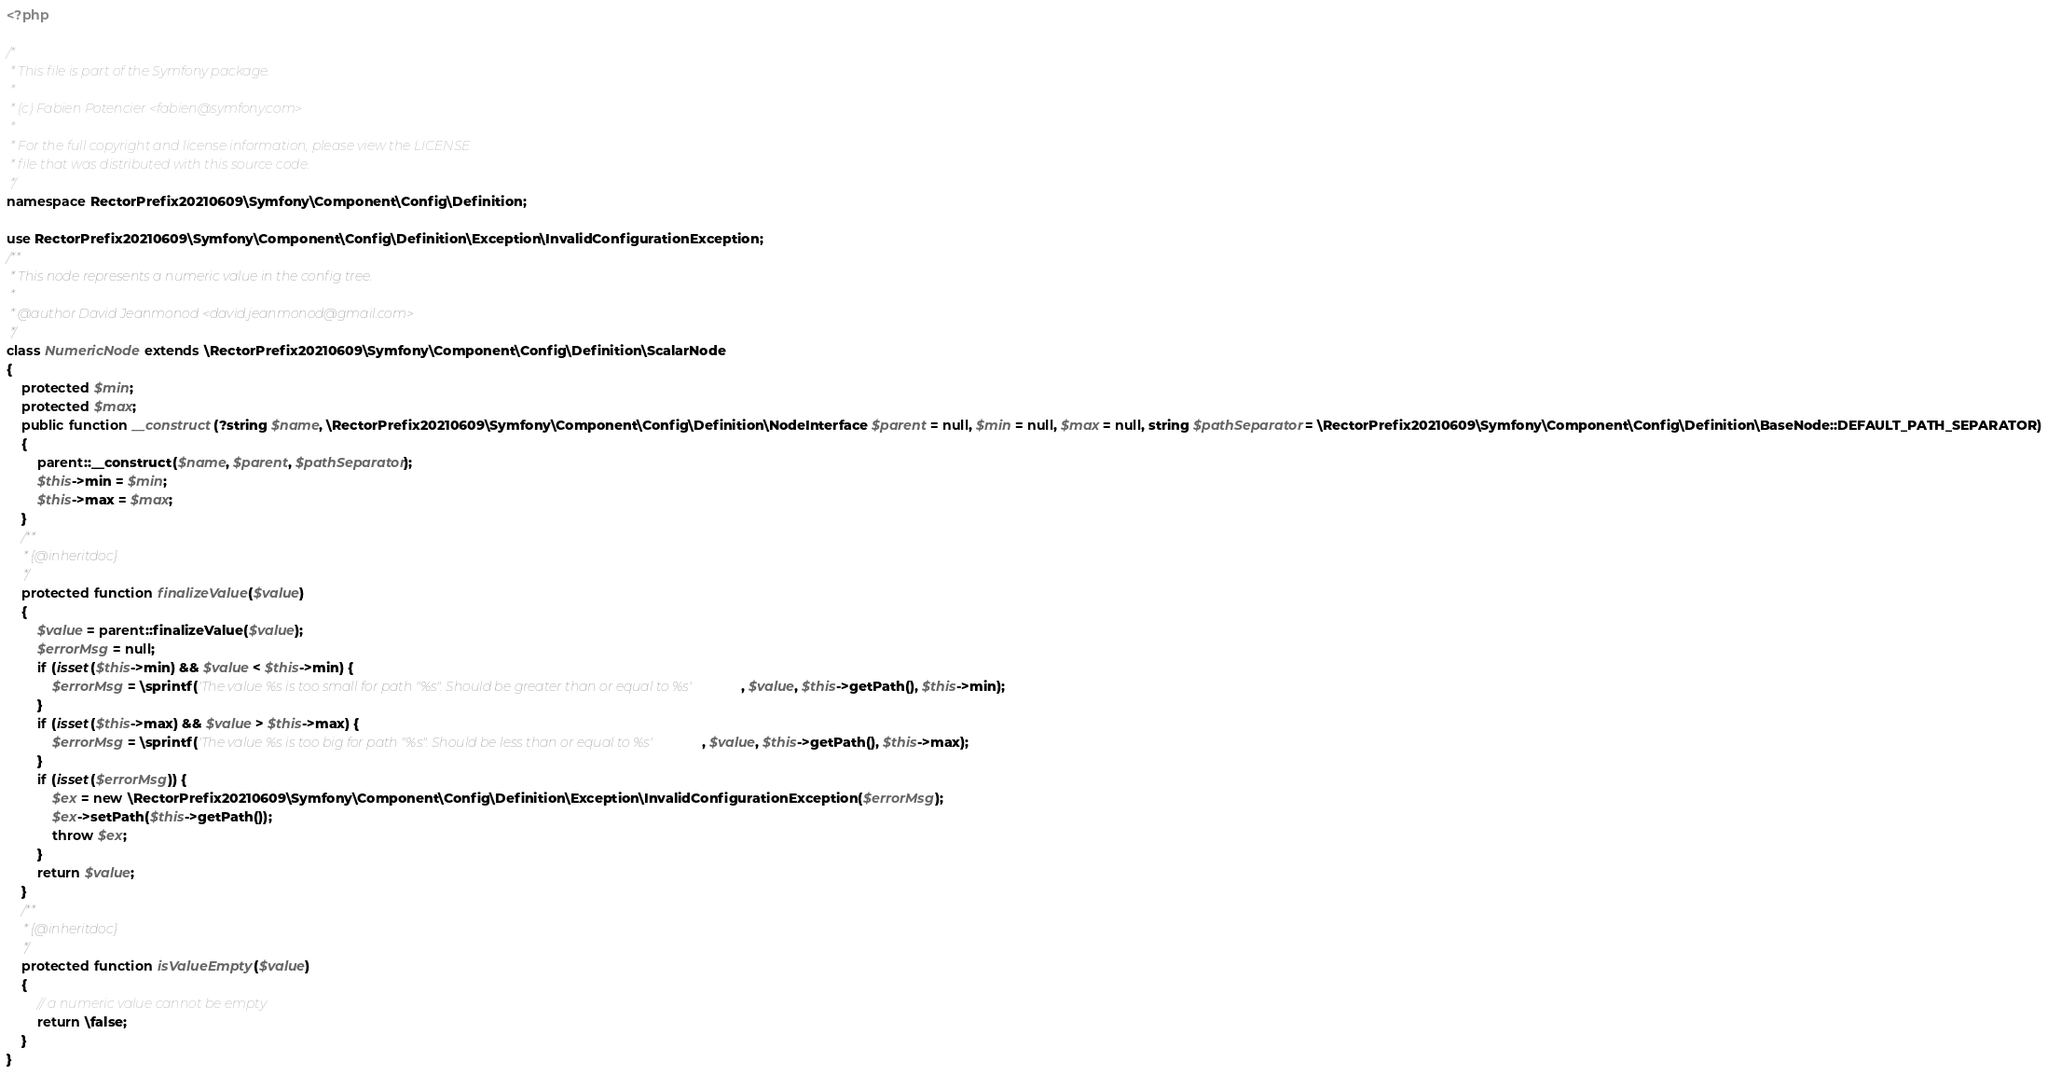<code> <loc_0><loc_0><loc_500><loc_500><_PHP_><?php

/*
 * This file is part of the Symfony package.
 *
 * (c) Fabien Potencier <fabien@symfony.com>
 *
 * For the full copyright and license information, please view the LICENSE
 * file that was distributed with this source code.
 */
namespace RectorPrefix20210609\Symfony\Component\Config\Definition;

use RectorPrefix20210609\Symfony\Component\Config\Definition\Exception\InvalidConfigurationException;
/**
 * This node represents a numeric value in the config tree.
 *
 * @author David Jeanmonod <david.jeanmonod@gmail.com>
 */
class NumericNode extends \RectorPrefix20210609\Symfony\Component\Config\Definition\ScalarNode
{
    protected $min;
    protected $max;
    public function __construct(?string $name, \RectorPrefix20210609\Symfony\Component\Config\Definition\NodeInterface $parent = null, $min = null, $max = null, string $pathSeparator = \RectorPrefix20210609\Symfony\Component\Config\Definition\BaseNode::DEFAULT_PATH_SEPARATOR)
    {
        parent::__construct($name, $parent, $pathSeparator);
        $this->min = $min;
        $this->max = $max;
    }
    /**
     * {@inheritdoc}
     */
    protected function finalizeValue($value)
    {
        $value = parent::finalizeValue($value);
        $errorMsg = null;
        if (isset($this->min) && $value < $this->min) {
            $errorMsg = \sprintf('The value %s is too small for path "%s". Should be greater than or equal to %s', $value, $this->getPath(), $this->min);
        }
        if (isset($this->max) && $value > $this->max) {
            $errorMsg = \sprintf('The value %s is too big for path "%s". Should be less than or equal to %s', $value, $this->getPath(), $this->max);
        }
        if (isset($errorMsg)) {
            $ex = new \RectorPrefix20210609\Symfony\Component\Config\Definition\Exception\InvalidConfigurationException($errorMsg);
            $ex->setPath($this->getPath());
            throw $ex;
        }
        return $value;
    }
    /**
     * {@inheritdoc}
     */
    protected function isValueEmpty($value)
    {
        // a numeric value cannot be empty
        return \false;
    }
}
</code> 